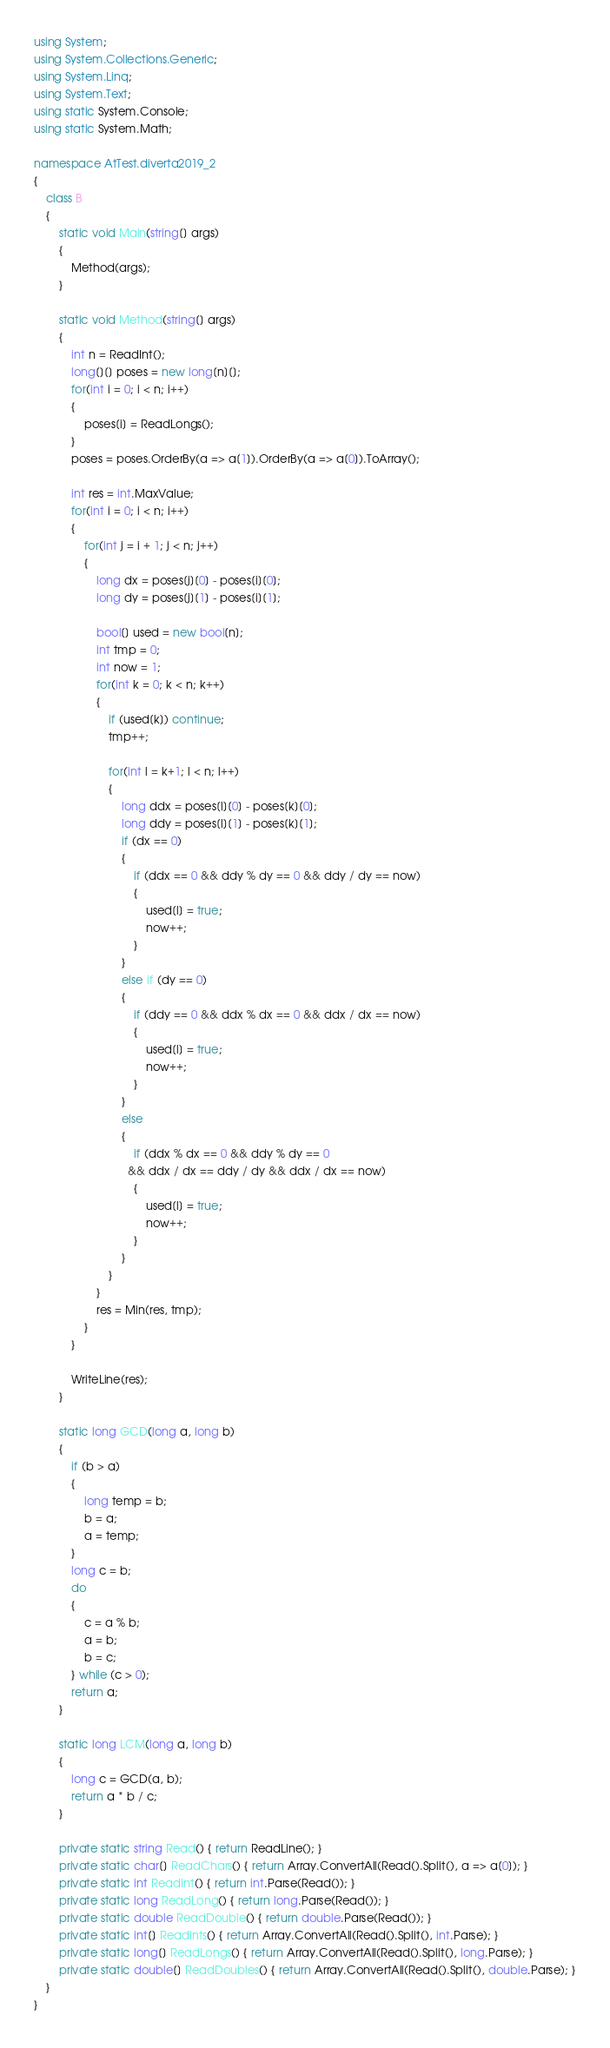<code> <loc_0><loc_0><loc_500><loc_500><_C#_>using System;
using System.Collections.Generic;
using System.Linq;
using System.Text;
using static System.Console;
using static System.Math;

namespace AtTest.diverta2019_2
{
    class B
    {
        static void Main(string[] args)
        {
            Method(args);
        }

        static void Method(string[] args)
        {
            int n = ReadInt();
            long[][] poses = new long[n][];
            for(int i = 0; i < n; i++)
            {
                poses[i] = ReadLongs();
            }
            poses = poses.OrderBy(a => a[1]).OrderBy(a => a[0]).ToArray();

            int res = int.MaxValue;
            for(int i = 0; i < n; i++)
            {
                for(int j = i + 1; j < n; j++)
                {
                    long dx = poses[j][0] - poses[i][0];
                    long dy = poses[j][1] - poses[i][1];

                    bool[] used = new bool[n];
                    int tmp = 0;
                    int now = 1;
                    for(int k = 0; k < n; k++)
                    {
                        if (used[k]) continue;
                        tmp++;

                        for(int l = k+1; l < n; l++)
                        {
                            long ddx = poses[l][0] - poses[k][0];
                            long ddy = poses[l][1] - poses[k][1];
                            if (dx == 0)
                            {
                                if (ddx == 0 && ddy % dy == 0 && ddy / dy == now)
                                {
                                    used[l] = true;
                                    now++;
                                }
                            }
                            else if (dy == 0)
                            {
                                if (ddy == 0 && ddx % dx == 0 && ddx / dx == now)
                                {
                                    used[l] = true;
                                    now++;
                                }
                            }
                            else
                            {
                                if (ddx % dx == 0 && ddy % dy == 0
                              && ddx / dx == ddy / dy && ddx / dx == now)
                                {
                                    used[l] = true;
                                    now++;
                                }
                            }
                        }
                    }
                    res = Min(res, tmp);
                }
            }

            WriteLine(res);
        }

        static long GCD(long a, long b)
        {
            if (b > a)
            {
                long temp = b;
                b = a;
                a = temp;
            }
            long c = b;
            do
            {
                c = a % b;
                a = b;
                b = c;
            } while (c > 0);
            return a;
        }

        static long LCM(long a, long b)
        {
            long c = GCD(a, b);
            return a * b / c;
        }

        private static string Read() { return ReadLine(); }
        private static char[] ReadChars() { return Array.ConvertAll(Read().Split(), a => a[0]); }
        private static int ReadInt() { return int.Parse(Read()); }
        private static long ReadLong() { return long.Parse(Read()); }
        private static double ReadDouble() { return double.Parse(Read()); }
        private static int[] ReadInts() { return Array.ConvertAll(Read().Split(), int.Parse); }
        private static long[] ReadLongs() { return Array.ConvertAll(Read().Split(), long.Parse); }
        private static double[] ReadDoubles() { return Array.ConvertAll(Read().Split(), double.Parse); }
    }
}
</code> 